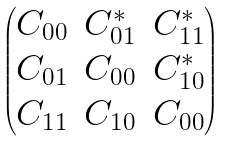<formula> <loc_0><loc_0><loc_500><loc_500>\begin{pmatrix} C _ { 0 0 } & C _ { 0 1 } ^ { * } & C _ { 1 1 } ^ { * } \\ C _ { 0 1 } & C _ { 0 0 } & C _ { 1 0 } ^ { * } \\ C _ { 1 1 } & C _ { 1 0 } & C _ { 0 0 } \\ \end{pmatrix}</formula> 